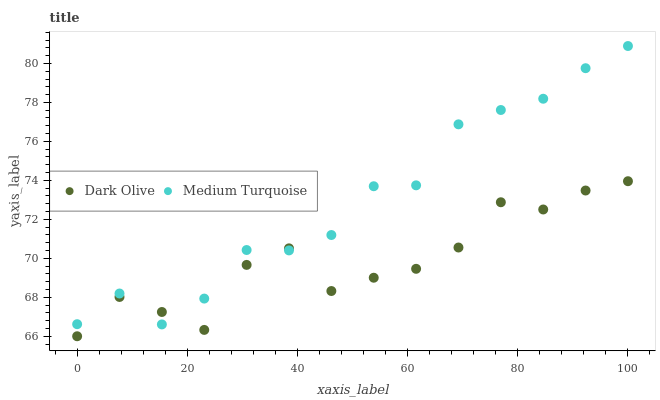Does Dark Olive have the minimum area under the curve?
Answer yes or no. Yes. Does Medium Turquoise have the maximum area under the curve?
Answer yes or no. Yes. Does Medium Turquoise have the minimum area under the curve?
Answer yes or no. No. Is Medium Turquoise the smoothest?
Answer yes or no. Yes. Is Dark Olive the roughest?
Answer yes or no. Yes. Is Medium Turquoise the roughest?
Answer yes or no. No. Does Dark Olive have the lowest value?
Answer yes or no. Yes. Does Medium Turquoise have the lowest value?
Answer yes or no. No. Does Medium Turquoise have the highest value?
Answer yes or no. Yes. Does Dark Olive intersect Medium Turquoise?
Answer yes or no. Yes. Is Dark Olive less than Medium Turquoise?
Answer yes or no. No. Is Dark Olive greater than Medium Turquoise?
Answer yes or no. No. 